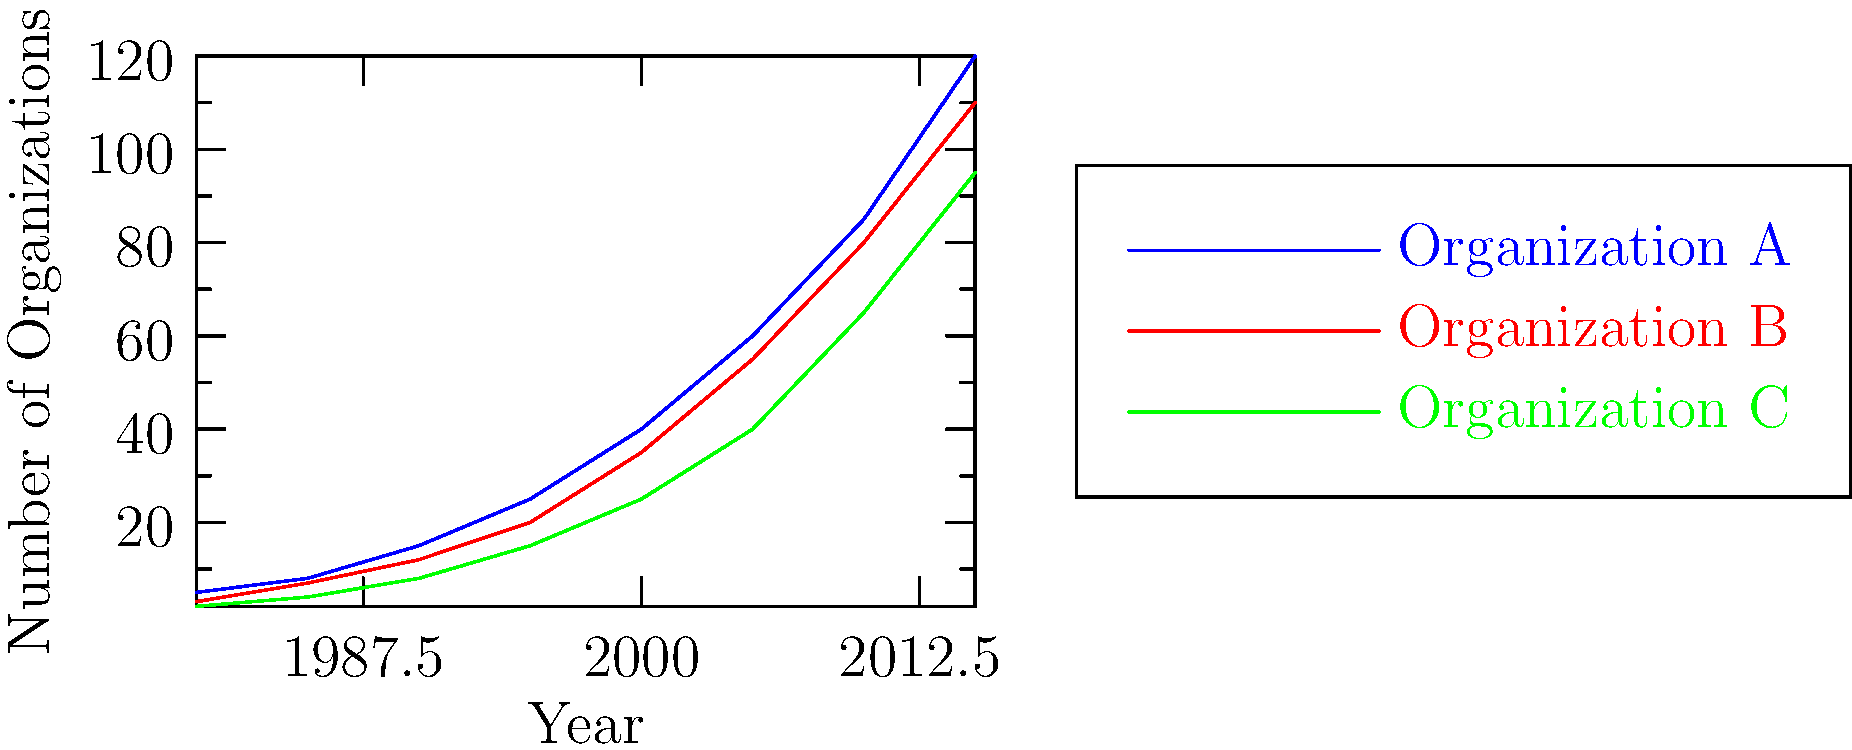The graph shows the growth of three women's rights organizations in Indonesia from 1980 to 2015. Which organization experienced the highest absolute increase in the number of organizations between 1990 and 2000? To determine which organization had the highest absolute increase between 1990 and 2000:

1. Identify the values for each organization in 1990 and 2000:
   Organization A: 1990 = 15, 2000 = 40
   Organization B: 1990 = 12, 2000 = 35
   Organization C: 1990 = 8, 2000 = 25

2. Calculate the absolute increase for each:
   Organization A: 40 - 15 = 25
   Organization B: 35 - 12 = 23
   Organization C: 25 - 8 = 17

3. Compare the increases:
   Organization A: 25
   Organization B: 23
   Organization C: 17

Organization A had the highest absolute increase of 25 organizations.
Answer: Organization A 